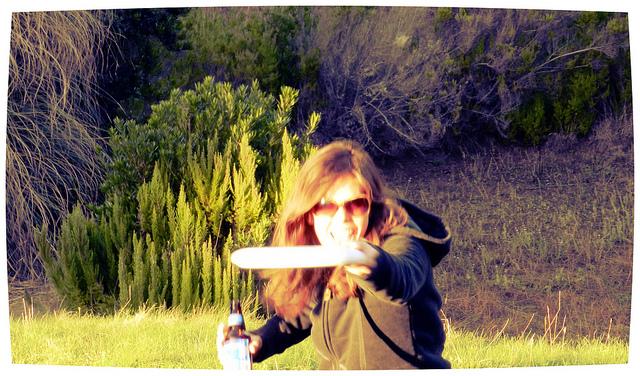Why is the bottle not made of clear glass?
Answer briefly. Beer bottle. Why is this person wearing glasses?
Answer briefly. It is sunny out. What is the woman holding in her right hand?
Give a very brief answer. Frisbee. 